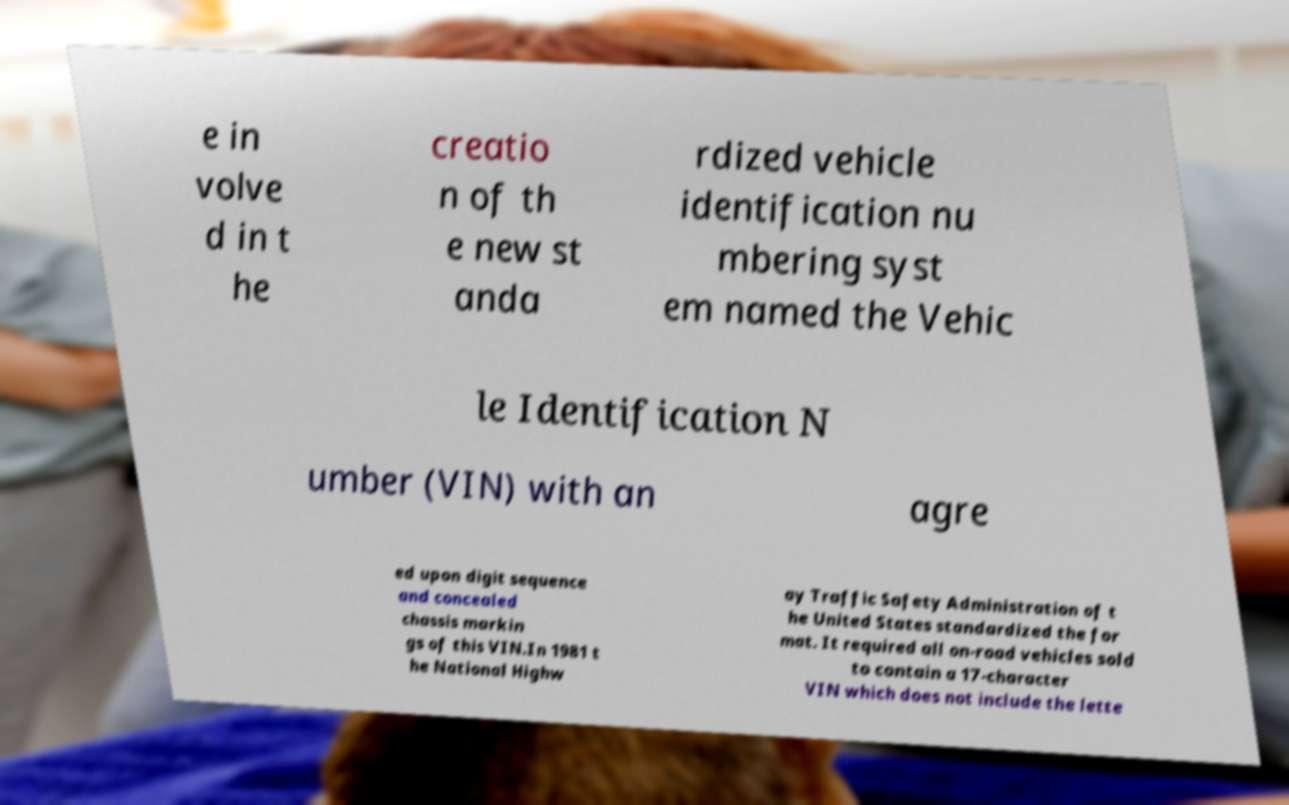Can you read and provide the text displayed in the image?This photo seems to have some interesting text. Can you extract and type it out for me? e in volve d in t he creatio n of th e new st anda rdized vehicle identification nu mbering syst em named the Vehic le Identification N umber (VIN) with an agre ed upon digit sequence and concealed chassis markin gs of this VIN.In 1981 t he National Highw ay Traffic Safety Administration of t he United States standardized the for mat. It required all on-road vehicles sold to contain a 17-character VIN which does not include the lette 